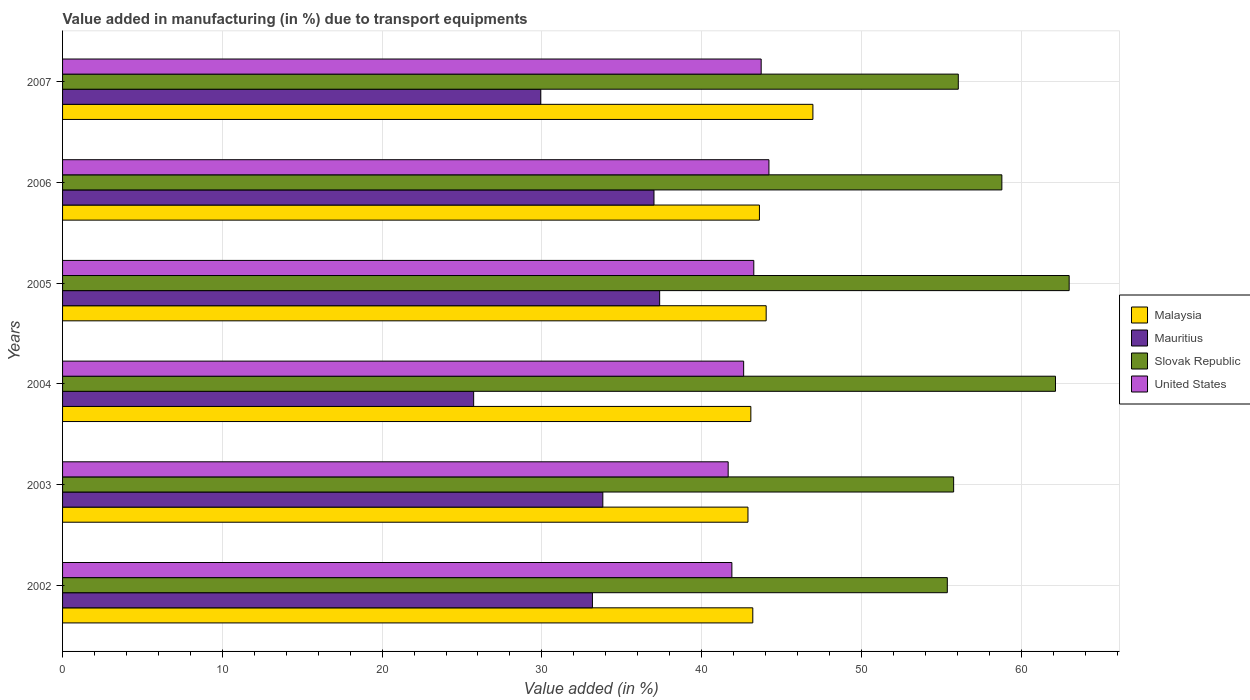How many different coloured bars are there?
Make the answer very short. 4. Are the number of bars on each tick of the Y-axis equal?
Provide a short and direct response. Yes. How many bars are there on the 6th tick from the bottom?
Give a very brief answer. 4. What is the percentage of value added in manufacturing due to transport equipments in Slovak Republic in 2006?
Your response must be concise. 58.79. Across all years, what is the maximum percentage of value added in manufacturing due to transport equipments in United States?
Your answer should be very brief. 44.21. Across all years, what is the minimum percentage of value added in manufacturing due to transport equipments in Slovak Republic?
Your answer should be compact. 55.38. What is the total percentage of value added in manufacturing due to transport equipments in Malaysia in the graph?
Keep it short and to the point. 263.79. What is the difference between the percentage of value added in manufacturing due to transport equipments in Slovak Republic in 2003 and that in 2007?
Offer a terse response. -0.29. What is the difference between the percentage of value added in manufacturing due to transport equipments in Malaysia in 2004 and the percentage of value added in manufacturing due to transport equipments in Slovak Republic in 2002?
Make the answer very short. -12.3. What is the average percentage of value added in manufacturing due to transport equipments in Slovak Republic per year?
Your response must be concise. 58.52. In the year 2005, what is the difference between the percentage of value added in manufacturing due to transport equipments in United States and percentage of value added in manufacturing due to transport equipments in Slovak Republic?
Offer a very short reply. -19.74. In how many years, is the percentage of value added in manufacturing due to transport equipments in United States greater than 16 %?
Provide a succinct answer. 6. What is the ratio of the percentage of value added in manufacturing due to transport equipments in United States in 2002 to that in 2004?
Keep it short and to the point. 0.98. Is the percentage of value added in manufacturing due to transport equipments in Malaysia in 2005 less than that in 2007?
Give a very brief answer. Yes. Is the difference between the percentage of value added in manufacturing due to transport equipments in United States in 2003 and 2005 greater than the difference between the percentage of value added in manufacturing due to transport equipments in Slovak Republic in 2003 and 2005?
Offer a very short reply. Yes. What is the difference between the highest and the second highest percentage of value added in manufacturing due to transport equipments in Mauritius?
Your answer should be very brief. 0.36. What is the difference between the highest and the lowest percentage of value added in manufacturing due to transport equipments in Mauritius?
Your answer should be very brief. 11.64. Is the sum of the percentage of value added in manufacturing due to transport equipments in Slovak Republic in 2003 and 2004 greater than the maximum percentage of value added in manufacturing due to transport equipments in Mauritius across all years?
Make the answer very short. Yes. Is it the case that in every year, the sum of the percentage of value added in manufacturing due to transport equipments in Slovak Republic and percentage of value added in manufacturing due to transport equipments in United States is greater than the sum of percentage of value added in manufacturing due to transport equipments in Mauritius and percentage of value added in manufacturing due to transport equipments in Malaysia?
Your response must be concise. No. What does the 4th bar from the top in 2007 represents?
Ensure brevity in your answer.  Malaysia. Does the graph contain any zero values?
Give a very brief answer. No. Does the graph contain grids?
Offer a terse response. Yes. What is the title of the graph?
Your answer should be very brief. Value added in manufacturing (in %) due to transport equipments. What is the label or title of the X-axis?
Your answer should be very brief. Value added (in %). What is the Value added (in %) in Malaysia in 2002?
Your answer should be compact. 43.2. What is the Value added (in %) of Mauritius in 2002?
Offer a very short reply. 33.16. What is the Value added (in %) in Slovak Republic in 2002?
Your answer should be compact. 55.38. What is the Value added (in %) of United States in 2002?
Keep it short and to the point. 41.89. What is the Value added (in %) of Malaysia in 2003?
Offer a very short reply. 42.9. What is the Value added (in %) of Mauritius in 2003?
Ensure brevity in your answer.  33.81. What is the Value added (in %) in Slovak Republic in 2003?
Make the answer very short. 55.77. What is the Value added (in %) of United States in 2003?
Provide a short and direct response. 41.66. What is the Value added (in %) of Malaysia in 2004?
Your response must be concise. 43.08. What is the Value added (in %) of Mauritius in 2004?
Give a very brief answer. 25.73. What is the Value added (in %) in Slovak Republic in 2004?
Your answer should be very brief. 62.15. What is the Value added (in %) of United States in 2004?
Offer a terse response. 42.63. What is the Value added (in %) of Malaysia in 2005?
Ensure brevity in your answer.  44.04. What is the Value added (in %) in Mauritius in 2005?
Ensure brevity in your answer.  37.37. What is the Value added (in %) in Slovak Republic in 2005?
Keep it short and to the point. 63. What is the Value added (in %) of United States in 2005?
Offer a very short reply. 43.26. What is the Value added (in %) of Malaysia in 2006?
Provide a short and direct response. 43.62. What is the Value added (in %) of Mauritius in 2006?
Make the answer very short. 37.02. What is the Value added (in %) in Slovak Republic in 2006?
Your answer should be compact. 58.79. What is the Value added (in %) of United States in 2006?
Offer a very short reply. 44.21. What is the Value added (in %) in Malaysia in 2007?
Offer a terse response. 46.96. What is the Value added (in %) in Mauritius in 2007?
Ensure brevity in your answer.  29.93. What is the Value added (in %) in Slovak Republic in 2007?
Offer a very short reply. 56.06. What is the Value added (in %) of United States in 2007?
Your response must be concise. 43.73. Across all years, what is the maximum Value added (in %) of Malaysia?
Your answer should be compact. 46.96. Across all years, what is the maximum Value added (in %) of Mauritius?
Your answer should be very brief. 37.37. Across all years, what is the maximum Value added (in %) in Slovak Republic?
Offer a very short reply. 63. Across all years, what is the maximum Value added (in %) of United States?
Offer a very short reply. 44.21. Across all years, what is the minimum Value added (in %) in Malaysia?
Keep it short and to the point. 42.9. Across all years, what is the minimum Value added (in %) of Mauritius?
Offer a terse response. 25.73. Across all years, what is the minimum Value added (in %) of Slovak Republic?
Your response must be concise. 55.38. Across all years, what is the minimum Value added (in %) of United States?
Ensure brevity in your answer.  41.66. What is the total Value added (in %) in Malaysia in the graph?
Keep it short and to the point. 263.79. What is the total Value added (in %) in Mauritius in the graph?
Ensure brevity in your answer.  197.02. What is the total Value added (in %) of Slovak Republic in the graph?
Make the answer very short. 351.15. What is the total Value added (in %) in United States in the graph?
Offer a terse response. 257.38. What is the difference between the Value added (in %) in Malaysia in 2002 and that in 2003?
Offer a very short reply. 0.3. What is the difference between the Value added (in %) in Mauritius in 2002 and that in 2003?
Give a very brief answer. -0.65. What is the difference between the Value added (in %) in Slovak Republic in 2002 and that in 2003?
Keep it short and to the point. -0.4. What is the difference between the Value added (in %) in United States in 2002 and that in 2003?
Your answer should be very brief. 0.23. What is the difference between the Value added (in %) in Malaysia in 2002 and that in 2004?
Your answer should be compact. 0.12. What is the difference between the Value added (in %) in Mauritius in 2002 and that in 2004?
Offer a very short reply. 7.43. What is the difference between the Value added (in %) of Slovak Republic in 2002 and that in 2004?
Provide a succinct answer. -6.77. What is the difference between the Value added (in %) of United States in 2002 and that in 2004?
Give a very brief answer. -0.74. What is the difference between the Value added (in %) of Malaysia in 2002 and that in 2005?
Your answer should be compact. -0.84. What is the difference between the Value added (in %) in Mauritius in 2002 and that in 2005?
Ensure brevity in your answer.  -4.21. What is the difference between the Value added (in %) in Slovak Republic in 2002 and that in 2005?
Keep it short and to the point. -7.63. What is the difference between the Value added (in %) of United States in 2002 and that in 2005?
Your answer should be compact. -1.37. What is the difference between the Value added (in %) of Malaysia in 2002 and that in 2006?
Ensure brevity in your answer.  -0.42. What is the difference between the Value added (in %) of Mauritius in 2002 and that in 2006?
Your answer should be very brief. -3.85. What is the difference between the Value added (in %) in Slovak Republic in 2002 and that in 2006?
Give a very brief answer. -3.41. What is the difference between the Value added (in %) of United States in 2002 and that in 2006?
Ensure brevity in your answer.  -2.32. What is the difference between the Value added (in %) in Malaysia in 2002 and that in 2007?
Provide a succinct answer. -3.76. What is the difference between the Value added (in %) of Mauritius in 2002 and that in 2007?
Give a very brief answer. 3.24. What is the difference between the Value added (in %) of Slovak Republic in 2002 and that in 2007?
Your answer should be very brief. -0.69. What is the difference between the Value added (in %) of United States in 2002 and that in 2007?
Keep it short and to the point. -1.83. What is the difference between the Value added (in %) in Malaysia in 2003 and that in 2004?
Make the answer very short. -0.18. What is the difference between the Value added (in %) in Mauritius in 2003 and that in 2004?
Offer a very short reply. 8.09. What is the difference between the Value added (in %) in Slovak Republic in 2003 and that in 2004?
Offer a terse response. -6.37. What is the difference between the Value added (in %) in United States in 2003 and that in 2004?
Provide a succinct answer. -0.97. What is the difference between the Value added (in %) of Malaysia in 2003 and that in 2005?
Provide a succinct answer. -1.14. What is the difference between the Value added (in %) of Mauritius in 2003 and that in 2005?
Give a very brief answer. -3.56. What is the difference between the Value added (in %) of Slovak Republic in 2003 and that in 2005?
Provide a succinct answer. -7.23. What is the difference between the Value added (in %) of United States in 2003 and that in 2005?
Give a very brief answer. -1.6. What is the difference between the Value added (in %) in Malaysia in 2003 and that in 2006?
Give a very brief answer. -0.72. What is the difference between the Value added (in %) of Mauritius in 2003 and that in 2006?
Your answer should be very brief. -3.2. What is the difference between the Value added (in %) in Slovak Republic in 2003 and that in 2006?
Your response must be concise. -3.02. What is the difference between the Value added (in %) of United States in 2003 and that in 2006?
Your answer should be very brief. -2.55. What is the difference between the Value added (in %) of Malaysia in 2003 and that in 2007?
Make the answer very short. -4.06. What is the difference between the Value added (in %) of Mauritius in 2003 and that in 2007?
Your answer should be compact. 3.89. What is the difference between the Value added (in %) of Slovak Republic in 2003 and that in 2007?
Keep it short and to the point. -0.29. What is the difference between the Value added (in %) in United States in 2003 and that in 2007?
Give a very brief answer. -2.07. What is the difference between the Value added (in %) of Malaysia in 2004 and that in 2005?
Provide a succinct answer. -0.96. What is the difference between the Value added (in %) of Mauritius in 2004 and that in 2005?
Give a very brief answer. -11.64. What is the difference between the Value added (in %) of Slovak Republic in 2004 and that in 2005?
Ensure brevity in your answer.  -0.86. What is the difference between the Value added (in %) of United States in 2004 and that in 2005?
Offer a very short reply. -0.63. What is the difference between the Value added (in %) of Malaysia in 2004 and that in 2006?
Keep it short and to the point. -0.54. What is the difference between the Value added (in %) in Mauritius in 2004 and that in 2006?
Give a very brief answer. -11.29. What is the difference between the Value added (in %) of Slovak Republic in 2004 and that in 2006?
Your answer should be compact. 3.36. What is the difference between the Value added (in %) in United States in 2004 and that in 2006?
Offer a very short reply. -1.58. What is the difference between the Value added (in %) of Malaysia in 2004 and that in 2007?
Keep it short and to the point. -3.88. What is the difference between the Value added (in %) in Mauritius in 2004 and that in 2007?
Provide a succinct answer. -4.2. What is the difference between the Value added (in %) of Slovak Republic in 2004 and that in 2007?
Your response must be concise. 6.08. What is the difference between the Value added (in %) of United States in 2004 and that in 2007?
Offer a terse response. -1.1. What is the difference between the Value added (in %) of Malaysia in 2005 and that in 2006?
Offer a very short reply. 0.42. What is the difference between the Value added (in %) of Mauritius in 2005 and that in 2006?
Provide a short and direct response. 0.36. What is the difference between the Value added (in %) in Slovak Republic in 2005 and that in 2006?
Offer a terse response. 4.21. What is the difference between the Value added (in %) in United States in 2005 and that in 2006?
Make the answer very short. -0.95. What is the difference between the Value added (in %) in Malaysia in 2005 and that in 2007?
Give a very brief answer. -2.93. What is the difference between the Value added (in %) of Mauritius in 2005 and that in 2007?
Your answer should be very brief. 7.44. What is the difference between the Value added (in %) of Slovak Republic in 2005 and that in 2007?
Ensure brevity in your answer.  6.94. What is the difference between the Value added (in %) in United States in 2005 and that in 2007?
Offer a terse response. -0.46. What is the difference between the Value added (in %) of Malaysia in 2006 and that in 2007?
Offer a very short reply. -3.35. What is the difference between the Value added (in %) in Mauritius in 2006 and that in 2007?
Give a very brief answer. 7.09. What is the difference between the Value added (in %) in Slovak Republic in 2006 and that in 2007?
Offer a terse response. 2.73. What is the difference between the Value added (in %) in United States in 2006 and that in 2007?
Give a very brief answer. 0.49. What is the difference between the Value added (in %) in Malaysia in 2002 and the Value added (in %) in Mauritius in 2003?
Give a very brief answer. 9.39. What is the difference between the Value added (in %) in Malaysia in 2002 and the Value added (in %) in Slovak Republic in 2003?
Offer a terse response. -12.57. What is the difference between the Value added (in %) in Malaysia in 2002 and the Value added (in %) in United States in 2003?
Keep it short and to the point. 1.54. What is the difference between the Value added (in %) of Mauritius in 2002 and the Value added (in %) of Slovak Republic in 2003?
Offer a terse response. -22.61. What is the difference between the Value added (in %) of Mauritius in 2002 and the Value added (in %) of United States in 2003?
Provide a short and direct response. -8.49. What is the difference between the Value added (in %) of Slovak Republic in 2002 and the Value added (in %) of United States in 2003?
Provide a short and direct response. 13.72. What is the difference between the Value added (in %) of Malaysia in 2002 and the Value added (in %) of Mauritius in 2004?
Make the answer very short. 17.47. What is the difference between the Value added (in %) in Malaysia in 2002 and the Value added (in %) in Slovak Republic in 2004?
Your response must be concise. -18.95. What is the difference between the Value added (in %) in Malaysia in 2002 and the Value added (in %) in United States in 2004?
Your answer should be very brief. 0.57. What is the difference between the Value added (in %) of Mauritius in 2002 and the Value added (in %) of Slovak Republic in 2004?
Your response must be concise. -28.98. What is the difference between the Value added (in %) of Mauritius in 2002 and the Value added (in %) of United States in 2004?
Your answer should be compact. -9.46. What is the difference between the Value added (in %) in Slovak Republic in 2002 and the Value added (in %) in United States in 2004?
Keep it short and to the point. 12.75. What is the difference between the Value added (in %) in Malaysia in 2002 and the Value added (in %) in Mauritius in 2005?
Provide a succinct answer. 5.83. What is the difference between the Value added (in %) in Malaysia in 2002 and the Value added (in %) in Slovak Republic in 2005?
Your answer should be compact. -19.8. What is the difference between the Value added (in %) of Malaysia in 2002 and the Value added (in %) of United States in 2005?
Offer a very short reply. -0.06. What is the difference between the Value added (in %) in Mauritius in 2002 and the Value added (in %) in Slovak Republic in 2005?
Ensure brevity in your answer.  -29.84. What is the difference between the Value added (in %) of Mauritius in 2002 and the Value added (in %) of United States in 2005?
Provide a short and direct response. -10.1. What is the difference between the Value added (in %) in Slovak Republic in 2002 and the Value added (in %) in United States in 2005?
Make the answer very short. 12.11. What is the difference between the Value added (in %) of Malaysia in 2002 and the Value added (in %) of Mauritius in 2006?
Offer a terse response. 6.18. What is the difference between the Value added (in %) in Malaysia in 2002 and the Value added (in %) in Slovak Republic in 2006?
Make the answer very short. -15.59. What is the difference between the Value added (in %) in Malaysia in 2002 and the Value added (in %) in United States in 2006?
Offer a very short reply. -1.01. What is the difference between the Value added (in %) of Mauritius in 2002 and the Value added (in %) of Slovak Republic in 2006?
Ensure brevity in your answer.  -25.63. What is the difference between the Value added (in %) in Mauritius in 2002 and the Value added (in %) in United States in 2006?
Make the answer very short. -11.05. What is the difference between the Value added (in %) in Slovak Republic in 2002 and the Value added (in %) in United States in 2006?
Make the answer very short. 11.17. What is the difference between the Value added (in %) in Malaysia in 2002 and the Value added (in %) in Mauritius in 2007?
Provide a succinct answer. 13.27. What is the difference between the Value added (in %) of Malaysia in 2002 and the Value added (in %) of Slovak Republic in 2007?
Your answer should be very brief. -12.86. What is the difference between the Value added (in %) of Malaysia in 2002 and the Value added (in %) of United States in 2007?
Ensure brevity in your answer.  -0.52. What is the difference between the Value added (in %) in Mauritius in 2002 and the Value added (in %) in Slovak Republic in 2007?
Provide a succinct answer. -22.9. What is the difference between the Value added (in %) in Mauritius in 2002 and the Value added (in %) in United States in 2007?
Offer a very short reply. -10.56. What is the difference between the Value added (in %) of Slovak Republic in 2002 and the Value added (in %) of United States in 2007?
Provide a succinct answer. 11.65. What is the difference between the Value added (in %) of Malaysia in 2003 and the Value added (in %) of Mauritius in 2004?
Your response must be concise. 17.17. What is the difference between the Value added (in %) in Malaysia in 2003 and the Value added (in %) in Slovak Republic in 2004?
Your response must be concise. -19.25. What is the difference between the Value added (in %) of Malaysia in 2003 and the Value added (in %) of United States in 2004?
Make the answer very short. 0.27. What is the difference between the Value added (in %) in Mauritius in 2003 and the Value added (in %) in Slovak Republic in 2004?
Offer a terse response. -28.33. What is the difference between the Value added (in %) in Mauritius in 2003 and the Value added (in %) in United States in 2004?
Offer a terse response. -8.81. What is the difference between the Value added (in %) in Slovak Republic in 2003 and the Value added (in %) in United States in 2004?
Keep it short and to the point. 13.14. What is the difference between the Value added (in %) of Malaysia in 2003 and the Value added (in %) of Mauritius in 2005?
Offer a terse response. 5.53. What is the difference between the Value added (in %) of Malaysia in 2003 and the Value added (in %) of Slovak Republic in 2005?
Keep it short and to the point. -20.1. What is the difference between the Value added (in %) of Malaysia in 2003 and the Value added (in %) of United States in 2005?
Your answer should be compact. -0.37. What is the difference between the Value added (in %) of Mauritius in 2003 and the Value added (in %) of Slovak Republic in 2005?
Offer a terse response. -29.19. What is the difference between the Value added (in %) in Mauritius in 2003 and the Value added (in %) in United States in 2005?
Ensure brevity in your answer.  -9.45. What is the difference between the Value added (in %) of Slovak Republic in 2003 and the Value added (in %) of United States in 2005?
Offer a terse response. 12.51. What is the difference between the Value added (in %) in Malaysia in 2003 and the Value added (in %) in Mauritius in 2006?
Provide a short and direct response. 5.88. What is the difference between the Value added (in %) of Malaysia in 2003 and the Value added (in %) of Slovak Republic in 2006?
Ensure brevity in your answer.  -15.89. What is the difference between the Value added (in %) of Malaysia in 2003 and the Value added (in %) of United States in 2006?
Give a very brief answer. -1.31. What is the difference between the Value added (in %) in Mauritius in 2003 and the Value added (in %) in Slovak Republic in 2006?
Your answer should be very brief. -24.98. What is the difference between the Value added (in %) in Mauritius in 2003 and the Value added (in %) in United States in 2006?
Provide a short and direct response. -10.4. What is the difference between the Value added (in %) in Slovak Republic in 2003 and the Value added (in %) in United States in 2006?
Provide a succinct answer. 11.56. What is the difference between the Value added (in %) in Malaysia in 2003 and the Value added (in %) in Mauritius in 2007?
Offer a terse response. 12.97. What is the difference between the Value added (in %) of Malaysia in 2003 and the Value added (in %) of Slovak Republic in 2007?
Provide a succinct answer. -13.16. What is the difference between the Value added (in %) of Malaysia in 2003 and the Value added (in %) of United States in 2007?
Give a very brief answer. -0.83. What is the difference between the Value added (in %) in Mauritius in 2003 and the Value added (in %) in Slovak Republic in 2007?
Your response must be concise. -22.25. What is the difference between the Value added (in %) in Mauritius in 2003 and the Value added (in %) in United States in 2007?
Keep it short and to the point. -9.91. What is the difference between the Value added (in %) in Slovak Republic in 2003 and the Value added (in %) in United States in 2007?
Make the answer very short. 12.05. What is the difference between the Value added (in %) in Malaysia in 2004 and the Value added (in %) in Mauritius in 2005?
Keep it short and to the point. 5.71. What is the difference between the Value added (in %) in Malaysia in 2004 and the Value added (in %) in Slovak Republic in 2005?
Give a very brief answer. -19.92. What is the difference between the Value added (in %) in Malaysia in 2004 and the Value added (in %) in United States in 2005?
Provide a short and direct response. -0.18. What is the difference between the Value added (in %) of Mauritius in 2004 and the Value added (in %) of Slovak Republic in 2005?
Your answer should be very brief. -37.27. What is the difference between the Value added (in %) in Mauritius in 2004 and the Value added (in %) in United States in 2005?
Offer a terse response. -17.53. What is the difference between the Value added (in %) of Slovak Republic in 2004 and the Value added (in %) of United States in 2005?
Your answer should be compact. 18.88. What is the difference between the Value added (in %) of Malaysia in 2004 and the Value added (in %) of Mauritius in 2006?
Your answer should be compact. 6.06. What is the difference between the Value added (in %) of Malaysia in 2004 and the Value added (in %) of Slovak Republic in 2006?
Provide a short and direct response. -15.71. What is the difference between the Value added (in %) of Malaysia in 2004 and the Value added (in %) of United States in 2006?
Offer a very short reply. -1.13. What is the difference between the Value added (in %) of Mauritius in 2004 and the Value added (in %) of Slovak Republic in 2006?
Your answer should be very brief. -33.06. What is the difference between the Value added (in %) in Mauritius in 2004 and the Value added (in %) in United States in 2006?
Your answer should be very brief. -18.48. What is the difference between the Value added (in %) in Slovak Republic in 2004 and the Value added (in %) in United States in 2006?
Give a very brief answer. 17.94. What is the difference between the Value added (in %) in Malaysia in 2004 and the Value added (in %) in Mauritius in 2007?
Offer a terse response. 13.15. What is the difference between the Value added (in %) in Malaysia in 2004 and the Value added (in %) in Slovak Republic in 2007?
Make the answer very short. -12.98. What is the difference between the Value added (in %) of Malaysia in 2004 and the Value added (in %) of United States in 2007?
Your answer should be compact. -0.65. What is the difference between the Value added (in %) in Mauritius in 2004 and the Value added (in %) in Slovak Republic in 2007?
Ensure brevity in your answer.  -30.33. What is the difference between the Value added (in %) of Mauritius in 2004 and the Value added (in %) of United States in 2007?
Ensure brevity in your answer.  -18. What is the difference between the Value added (in %) in Slovak Republic in 2004 and the Value added (in %) in United States in 2007?
Provide a succinct answer. 18.42. What is the difference between the Value added (in %) of Malaysia in 2005 and the Value added (in %) of Mauritius in 2006?
Ensure brevity in your answer.  7.02. What is the difference between the Value added (in %) of Malaysia in 2005 and the Value added (in %) of Slovak Republic in 2006?
Make the answer very short. -14.75. What is the difference between the Value added (in %) of Malaysia in 2005 and the Value added (in %) of United States in 2006?
Give a very brief answer. -0.17. What is the difference between the Value added (in %) in Mauritius in 2005 and the Value added (in %) in Slovak Republic in 2006?
Ensure brevity in your answer.  -21.42. What is the difference between the Value added (in %) in Mauritius in 2005 and the Value added (in %) in United States in 2006?
Offer a terse response. -6.84. What is the difference between the Value added (in %) in Slovak Republic in 2005 and the Value added (in %) in United States in 2006?
Give a very brief answer. 18.79. What is the difference between the Value added (in %) of Malaysia in 2005 and the Value added (in %) of Mauritius in 2007?
Your answer should be compact. 14.11. What is the difference between the Value added (in %) of Malaysia in 2005 and the Value added (in %) of Slovak Republic in 2007?
Your answer should be compact. -12.03. What is the difference between the Value added (in %) in Malaysia in 2005 and the Value added (in %) in United States in 2007?
Your answer should be very brief. 0.31. What is the difference between the Value added (in %) in Mauritius in 2005 and the Value added (in %) in Slovak Republic in 2007?
Keep it short and to the point. -18.69. What is the difference between the Value added (in %) of Mauritius in 2005 and the Value added (in %) of United States in 2007?
Provide a short and direct response. -6.35. What is the difference between the Value added (in %) in Slovak Republic in 2005 and the Value added (in %) in United States in 2007?
Make the answer very short. 19.28. What is the difference between the Value added (in %) in Malaysia in 2006 and the Value added (in %) in Mauritius in 2007?
Ensure brevity in your answer.  13.69. What is the difference between the Value added (in %) in Malaysia in 2006 and the Value added (in %) in Slovak Republic in 2007?
Provide a succinct answer. -12.45. What is the difference between the Value added (in %) in Malaysia in 2006 and the Value added (in %) in United States in 2007?
Offer a terse response. -0.11. What is the difference between the Value added (in %) of Mauritius in 2006 and the Value added (in %) of Slovak Republic in 2007?
Provide a short and direct response. -19.05. What is the difference between the Value added (in %) of Mauritius in 2006 and the Value added (in %) of United States in 2007?
Keep it short and to the point. -6.71. What is the difference between the Value added (in %) in Slovak Republic in 2006 and the Value added (in %) in United States in 2007?
Your answer should be very brief. 15.06. What is the average Value added (in %) of Malaysia per year?
Provide a succinct answer. 43.97. What is the average Value added (in %) in Mauritius per year?
Make the answer very short. 32.84. What is the average Value added (in %) in Slovak Republic per year?
Ensure brevity in your answer.  58.52. What is the average Value added (in %) in United States per year?
Provide a short and direct response. 42.9. In the year 2002, what is the difference between the Value added (in %) of Malaysia and Value added (in %) of Mauritius?
Keep it short and to the point. 10.04. In the year 2002, what is the difference between the Value added (in %) in Malaysia and Value added (in %) in Slovak Republic?
Offer a terse response. -12.18. In the year 2002, what is the difference between the Value added (in %) of Malaysia and Value added (in %) of United States?
Provide a short and direct response. 1.31. In the year 2002, what is the difference between the Value added (in %) in Mauritius and Value added (in %) in Slovak Republic?
Provide a short and direct response. -22.21. In the year 2002, what is the difference between the Value added (in %) in Mauritius and Value added (in %) in United States?
Make the answer very short. -8.73. In the year 2002, what is the difference between the Value added (in %) in Slovak Republic and Value added (in %) in United States?
Keep it short and to the point. 13.48. In the year 2003, what is the difference between the Value added (in %) of Malaysia and Value added (in %) of Mauritius?
Provide a short and direct response. 9.08. In the year 2003, what is the difference between the Value added (in %) in Malaysia and Value added (in %) in Slovak Republic?
Offer a terse response. -12.87. In the year 2003, what is the difference between the Value added (in %) of Malaysia and Value added (in %) of United States?
Ensure brevity in your answer.  1.24. In the year 2003, what is the difference between the Value added (in %) of Mauritius and Value added (in %) of Slovak Republic?
Make the answer very short. -21.96. In the year 2003, what is the difference between the Value added (in %) in Mauritius and Value added (in %) in United States?
Give a very brief answer. -7.84. In the year 2003, what is the difference between the Value added (in %) of Slovak Republic and Value added (in %) of United States?
Your answer should be compact. 14.11. In the year 2004, what is the difference between the Value added (in %) of Malaysia and Value added (in %) of Mauritius?
Offer a very short reply. 17.35. In the year 2004, what is the difference between the Value added (in %) in Malaysia and Value added (in %) in Slovak Republic?
Keep it short and to the point. -19.07. In the year 2004, what is the difference between the Value added (in %) in Malaysia and Value added (in %) in United States?
Provide a succinct answer. 0.45. In the year 2004, what is the difference between the Value added (in %) in Mauritius and Value added (in %) in Slovak Republic?
Ensure brevity in your answer.  -36.42. In the year 2004, what is the difference between the Value added (in %) of Mauritius and Value added (in %) of United States?
Your answer should be very brief. -16.9. In the year 2004, what is the difference between the Value added (in %) of Slovak Republic and Value added (in %) of United States?
Make the answer very short. 19.52. In the year 2005, what is the difference between the Value added (in %) of Malaysia and Value added (in %) of Mauritius?
Your answer should be very brief. 6.67. In the year 2005, what is the difference between the Value added (in %) of Malaysia and Value added (in %) of Slovak Republic?
Ensure brevity in your answer.  -18.96. In the year 2005, what is the difference between the Value added (in %) in Malaysia and Value added (in %) in United States?
Your answer should be compact. 0.77. In the year 2005, what is the difference between the Value added (in %) in Mauritius and Value added (in %) in Slovak Republic?
Provide a succinct answer. -25.63. In the year 2005, what is the difference between the Value added (in %) in Mauritius and Value added (in %) in United States?
Keep it short and to the point. -5.89. In the year 2005, what is the difference between the Value added (in %) in Slovak Republic and Value added (in %) in United States?
Ensure brevity in your answer.  19.74. In the year 2006, what is the difference between the Value added (in %) of Malaysia and Value added (in %) of Mauritius?
Make the answer very short. 6.6. In the year 2006, what is the difference between the Value added (in %) of Malaysia and Value added (in %) of Slovak Republic?
Your answer should be compact. -15.17. In the year 2006, what is the difference between the Value added (in %) in Malaysia and Value added (in %) in United States?
Offer a terse response. -0.59. In the year 2006, what is the difference between the Value added (in %) of Mauritius and Value added (in %) of Slovak Republic?
Keep it short and to the point. -21.77. In the year 2006, what is the difference between the Value added (in %) of Mauritius and Value added (in %) of United States?
Ensure brevity in your answer.  -7.19. In the year 2006, what is the difference between the Value added (in %) of Slovak Republic and Value added (in %) of United States?
Provide a succinct answer. 14.58. In the year 2007, what is the difference between the Value added (in %) in Malaysia and Value added (in %) in Mauritius?
Give a very brief answer. 17.04. In the year 2007, what is the difference between the Value added (in %) of Malaysia and Value added (in %) of Slovak Republic?
Offer a terse response. -9.1. In the year 2007, what is the difference between the Value added (in %) of Malaysia and Value added (in %) of United States?
Offer a very short reply. 3.24. In the year 2007, what is the difference between the Value added (in %) of Mauritius and Value added (in %) of Slovak Republic?
Offer a very short reply. -26.14. In the year 2007, what is the difference between the Value added (in %) in Mauritius and Value added (in %) in United States?
Make the answer very short. -13.8. In the year 2007, what is the difference between the Value added (in %) in Slovak Republic and Value added (in %) in United States?
Keep it short and to the point. 12.34. What is the ratio of the Value added (in %) of Malaysia in 2002 to that in 2003?
Your answer should be compact. 1.01. What is the ratio of the Value added (in %) of Mauritius in 2002 to that in 2003?
Provide a short and direct response. 0.98. What is the ratio of the Value added (in %) of Slovak Republic in 2002 to that in 2003?
Keep it short and to the point. 0.99. What is the ratio of the Value added (in %) in United States in 2002 to that in 2003?
Make the answer very short. 1.01. What is the ratio of the Value added (in %) in Malaysia in 2002 to that in 2004?
Offer a terse response. 1. What is the ratio of the Value added (in %) in Mauritius in 2002 to that in 2004?
Keep it short and to the point. 1.29. What is the ratio of the Value added (in %) in Slovak Republic in 2002 to that in 2004?
Your answer should be very brief. 0.89. What is the ratio of the Value added (in %) in United States in 2002 to that in 2004?
Offer a very short reply. 0.98. What is the ratio of the Value added (in %) of Malaysia in 2002 to that in 2005?
Offer a terse response. 0.98. What is the ratio of the Value added (in %) in Mauritius in 2002 to that in 2005?
Your answer should be compact. 0.89. What is the ratio of the Value added (in %) in Slovak Republic in 2002 to that in 2005?
Provide a succinct answer. 0.88. What is the ratio of the Value added (in %) of United States in 2002 to that in 2005?
Your answer should be compact. 0.97. What is the ratio of the Value added (in %) in Malaysia in 2002 to that in 2006?
Keep it short and to the point. 0.99. What is the ratio of the Value added (in %) in Mauritius in 2002 to that in 2006?
Offer a terse response. 0.9. What is the ratio of the Value added (in %) in Slovak Republic in 2002 to that in 2006?
Provide a succinct answer. 0.94. What is the ratio of the Value added (in %) of United States in 2002 to that in 2006?
Provide a succinct answer. 0.95. What is the ratio of the Value added (in %) of Malaysia in 2002 to that in 2007?
Keep it short and to the point. 0.92. What is the ratio of the Value added (in %) of Mauritius in 2002 to that in 2007?
Make the answer very short. 1.11. What is the ratio of the Value added (in %) of United States in 2002 to that in 2007?
Your answer should be very brief. 0.96. What is the ratio of the Value added (in %) in Malaysia in 2003 to that in 2004?
Your response must be concise. 1. What is the ratio of the Value added (in %) of Mauritius in 2003 to that in 2004?
Offer a terse response. 1.31. What is the ratio of the Value added (in %) in Slovak Republic in 2003 to that in 2004?
Provide a short and direct response. 0.9. What is the ratio of the Value added (in %) of United States in 2003 to that in 2004?
Your response must be concise. 0.98. What is the ratio of the Value added (in %) in Malaysia in 2003 to that in 2005?
Your response must be concise. 0.97. What is the ratio of the Value added (in %) in Mauritius in 2003 to that in 2005?
Offer a very short reply. 0.9. What is the ratio of the Value added (in %) of Slovak Republic in 2003 to that in 2005?
Give a very brief answer. 0.89. What is the ratio of the Value added (in %) of United States in 2003 to that in 2005?
Ensure brevity in your answer.  0.96. What is the ratio of the Value added (in %) of Malaysia in 2003 to that in 2006?
Offer a terse response. 0.98. What is the ratio of the Value added (in %) in Mauritius in 2003 to that in 2006?
Your response must be concise. 0.91. What is the ratio of the Value added (in %) in Slovak Republic in 2003 to that in 2006?
Provide a succinct answer. 0.95. What is the ratio of the Value added (in %) of United States in 2003 to that in 2006?
Ensure brevity in your answer.  0.94. What is the ratio of the Value added (in %) in Malaysia in 2003 to that in 2007?
Your answer should be very brief. 0.91. What is the ratio of the Value added (in %) of Mauritius in 2003 to that in 2007?
Your answer should be compact. 1.13. What is the ratio of the Value added (in %) of Slovak Republic in 2003 to that in 2007?
Offer a very short reply. 0.99. What is the ratio of the Value added (in %) in United States in 2003 to that in 2007?
Your answer should be very brief. 0.95. What is the ratio of the Value added (in %) in Malaysia in 2004 to that in 2005?
Your answer should be compact. 0.98. What is the ratio of the Value added (in %) in Mauritius in 2004 to that in 2005?
Your answer should be very brief. 0.69. What is the ratio of the Value added (in %) of Slovak Republic in 2004 to that in 2005?
Your answer should be compact. 0.99. What is the ratio of the Value added (in %) in United States in 2004 to that in 2005?
Make the answer very short. 0.99. What is the ratio of the Value added (in %) of Mauritius in 2004 to that in 2006?
Your response must be concise. 0.7. What is the ratio of the Value added (in %) in Slovak Republic in 2004 to that in 2006?
Ensure brevity in your answer.  1.06. What is the ratio of the Value added (in %) in United States in 2004 to that in 2006?
Your answer should be compact. 0.96. What is the ratio of the Value added (in %) in Malaysia in 2004 to that in 2007?
Offer a very short reply. 0.92. What is the ratio of the Value added (in %) of Mauritius in 2004 to that in 2007?
Ensure brevity in your answer.  0.86. What is the ratio of the Value added (in %) of Slovak Republic in 2004 to that in 2007?
Ensure brevity in your answer.  1.11. What is the ratio of the Value added (in %) in United States in 2004 to that in 2007?
Provide a succinct answer. 0.97. What is the ratio of the Value added (in %) of Malaysia in 2005 to that in 2006?
Give a very brief answer. 1.01. What is the ratio of the Value added (in %) in Mauritius in 2005 to that in 2006?
Offer a very short reply. 1.01. What is the ratio of the Value added (in %) of Slovak Republic in 2005 to that in 2006?
Offer a terse response. 1.07. What is the ratio of the Value added (in %) of United States in 2005 to that in 2006?
Provide a succinct answer. 0.98. What is the ratio of the Value added (in %) of Malaysia in 2005 to that in 2007?
Your answer should be compact. 0.94. What is the ratio of the Value added (in %) of Mauritius in 2005 to that in 2007?
Your answer should be compact. 1.25. What is the ratio of the Value added (in %) of Slovak Republic in 2005 to that in 2007?
Keep it short and to the point. 1.12. What is the ratio of the Value added (in %) in Malaysia in 2006 to that in 2007?
Keep it short and to the point. 0.93. What is the ratio of the Value added (in %) of Mauritius in 2006 to that in 2007?
Your answer should be very brief. 1.24. What is the ratio of the Value added (in %) of Slovak Republic in 2006 to that in 2007?
Your answer should be compact. 1.05. What is the ratio of the Value added (in %) in United States in 2006 to that in 2007?
Provide a succinct answer. 1.01. What is the difference between the highest and the second highest Value added (in %) of Malaysia?
Your response must be concise. 2.93. What is the difference between the highest and the second highest Value added (in %) of Mauritius?
Offer a very short reply. 0.36. What is the difference between the highest and the second highest Value added (in %) in Slovak Republic?
Provide a succinct answer. 0.86. What is the difference between the highest and the second highest Value added (in %) in United States?
Your answer should be compact. 0.49. What is the difference between the highest and the lowest Value added (in %) in Malaysia?
Provide a succinct answer. 4.06. What is the difference between the highest and the lowest Value added (in %) of Mauritius?
Your response must be concise. 11.64. What is the difference between the highest and the lowest Value added (in %) of Slovak Republic?
Provide a short and direct response. 7.63. What is the difference between the highest and the lowest Value added (in %) of United States?
Give a very brief answer. 2.55. 